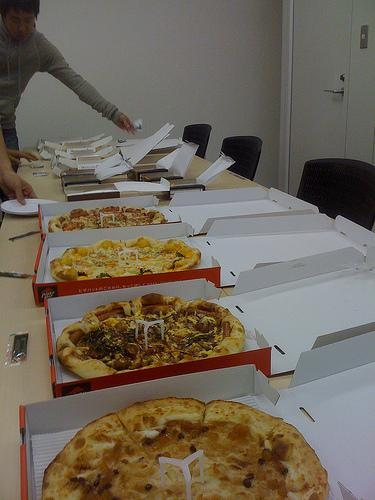Question: what is in the four large boxes?
Choices:
A. Pizza.
B. Sodas.
C. Napkins.
D. Plastic cutlery.
Answer with the letter. Answer: A Question: what is the small packet in front of the pizza box?
Choices:
A. A sauce packet.
B. Cheese.
C. Peppers.
D. Ketchup.
Answer with the letter. Answer: A Question: who made the pizza?
Choices:
A. Papa Johns Pizza.
B. Pizza Hut.
C. Dough Pizzeria.
D. Dominos Pizza.
Answer with the letter. Answer: B Question: why is this food here?
Choices:
A. To feed the kids.
B. To feed a group of people.
C. To feed the family.
D. To feed the workers.
Answer with the letter. Answer: B Question: how many pizzas are there?
Choices:
A. Three.
B. Four.
C. Two.
D. Five.
Answer with the letter. Answer: B 